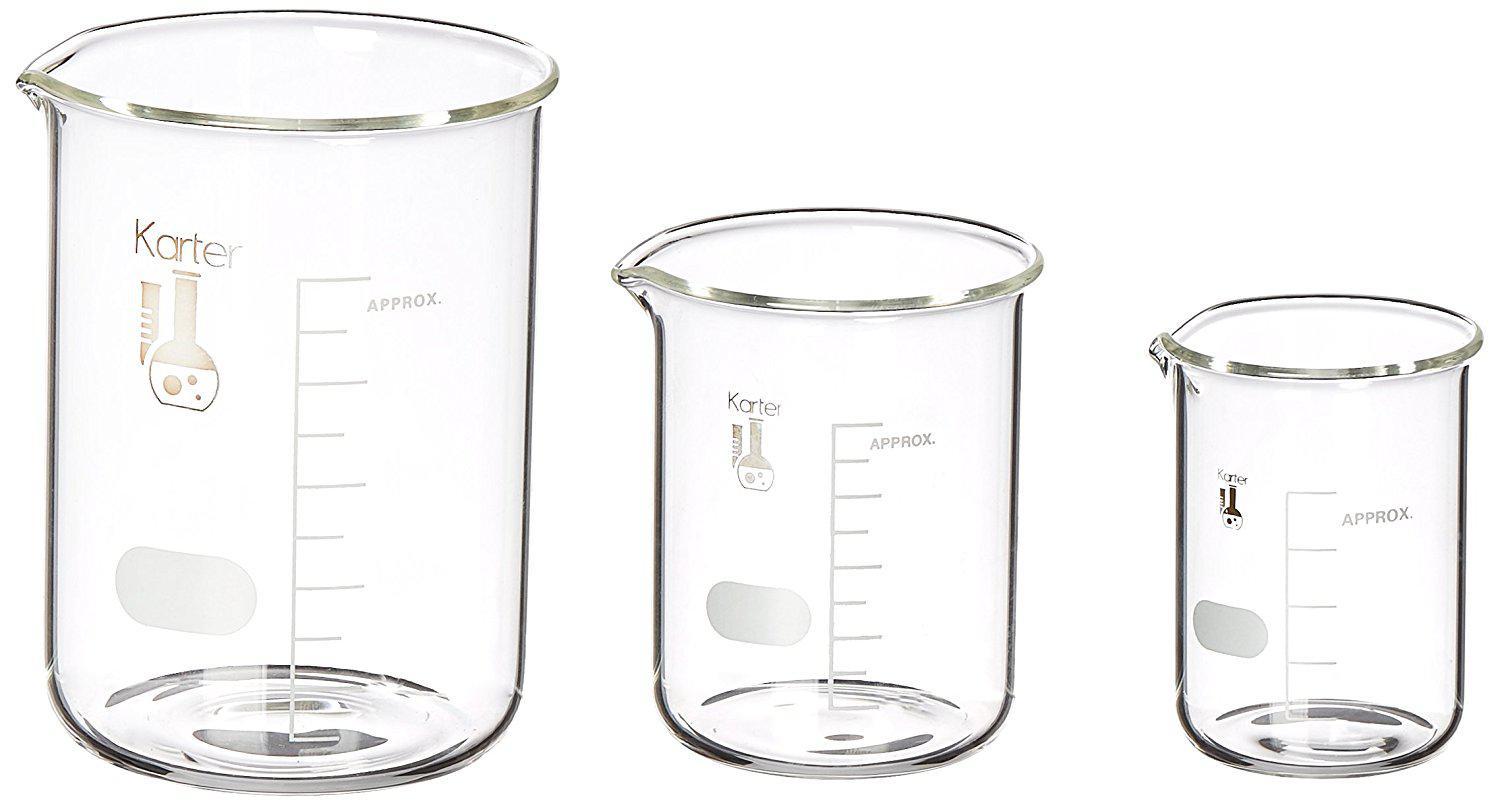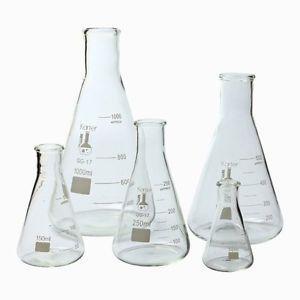The first image is the image on the left, the second image is the image on the right. Evaluate the accuracy of this statement regarding the images: "The image to the left contains a flask with a blue tinted liquid inside.". Is it true? Answer yes or no. No. The first image is the image on the left, the second image is the image on the right. For the images displayed, is the sentence "There is no less than one clear beaker filled with a blue liquid" factually correct? Answer yes or no. No. 